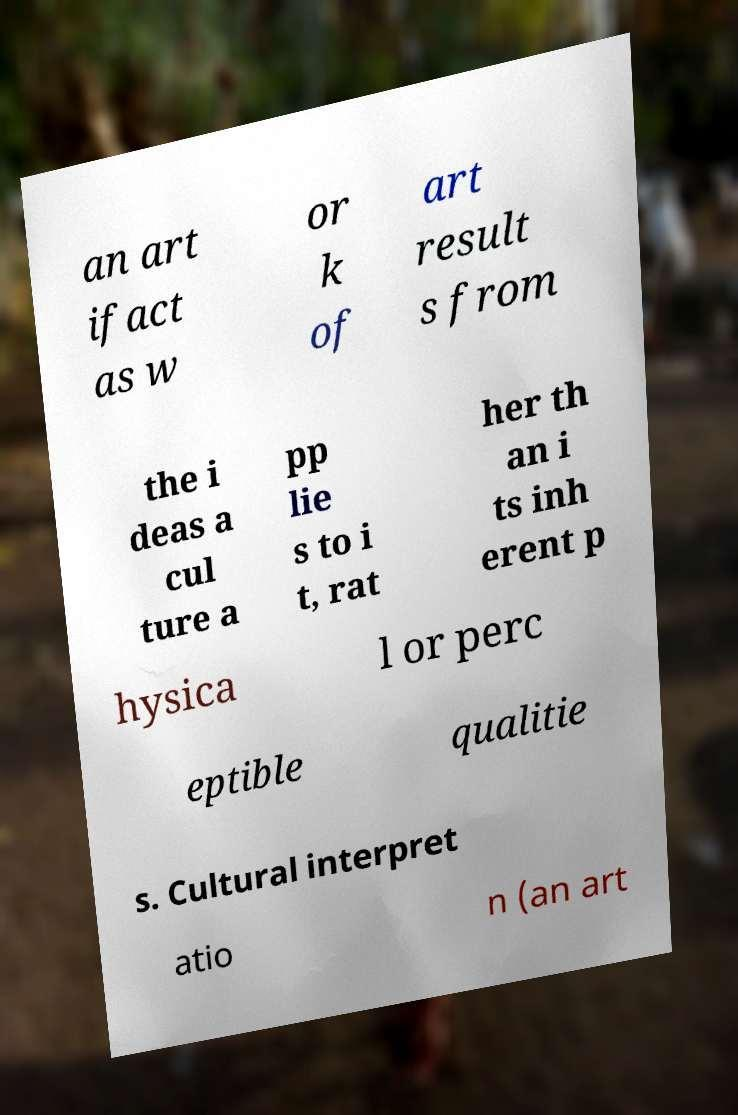I need the written content from this picture converted into text. Can you do that? an art ifact as w or k of art result s from the i deas a cul ture a pp lie s to i t, rat her th an i ts inh erent p hysica l or perc eptible qualitie s. Cultural interpret atio n (an art 